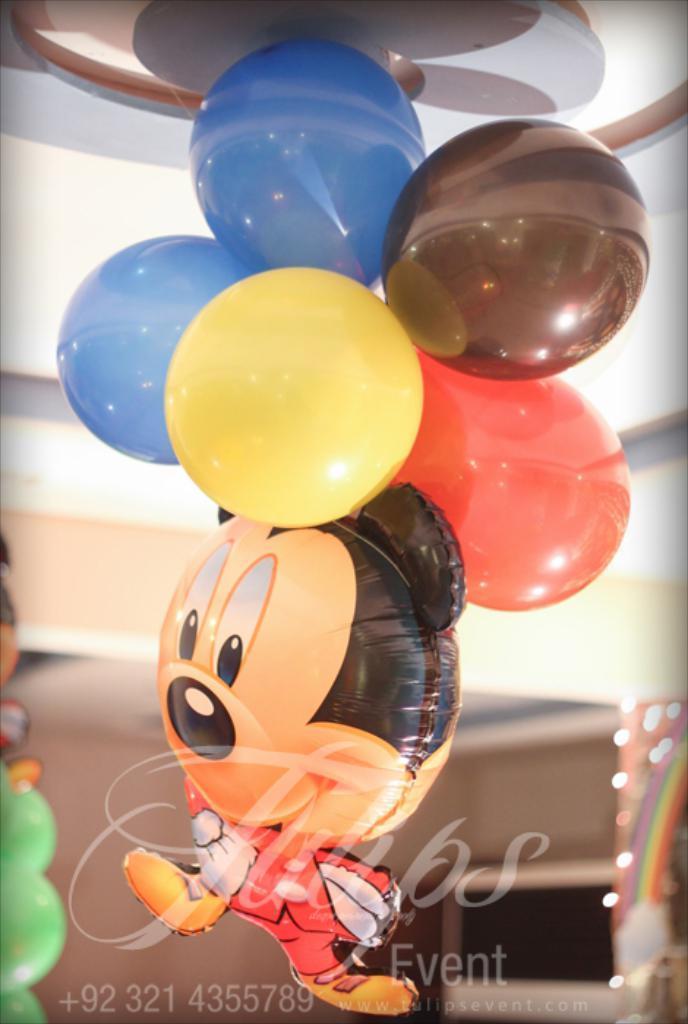Could you give a brief overview of what you see in this image? In this image I can see some balloons stick to the rooftop at the bottom of the image I can see some text. 